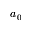<formula> <loc_0><loc_0><loc_500><loc_500>a _ { 0 }</formula> 